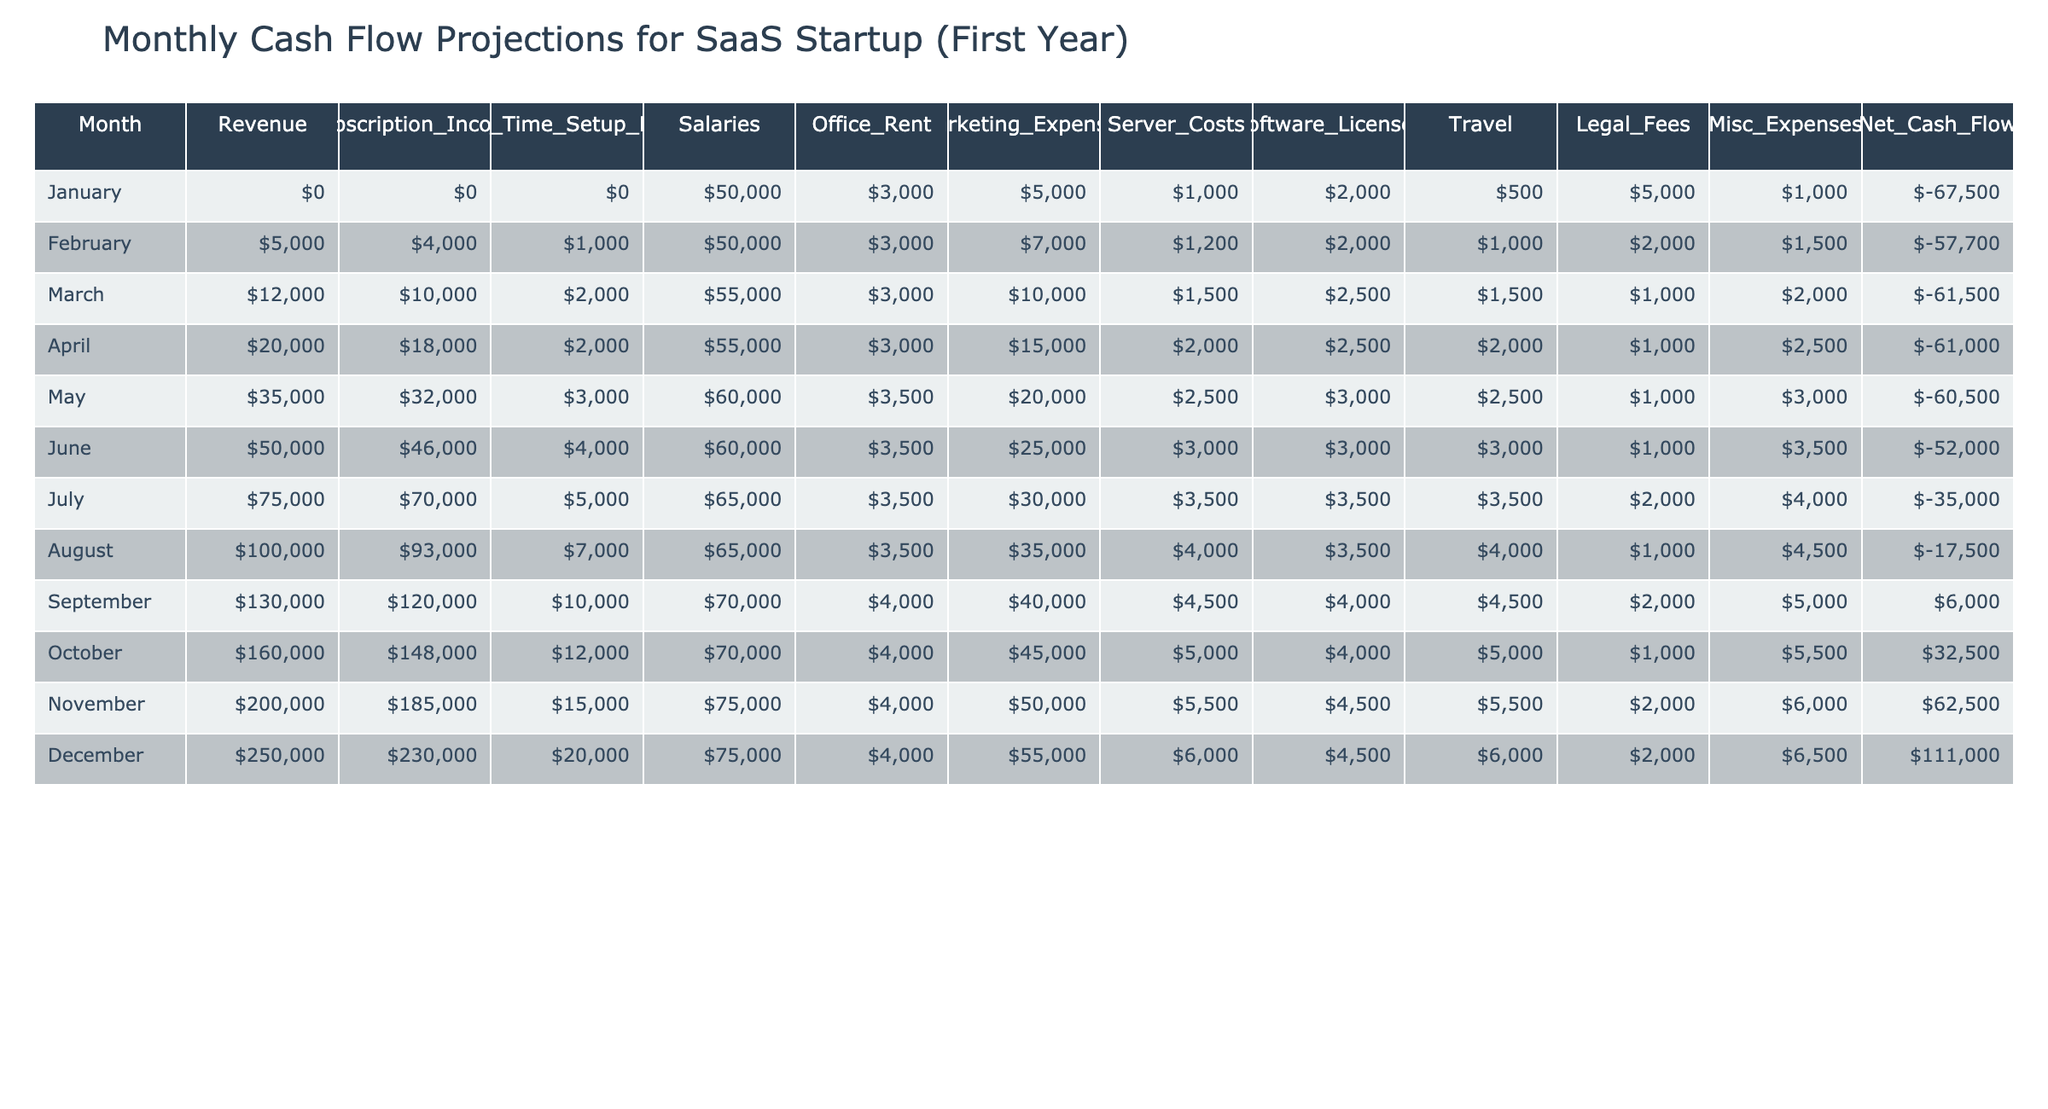What's the revenue in March? In the table, the revenue for March is listed directly in the corresponding row. It states that the revenue for March is $12,000.
Answer: $12,000 What is the total expenditure for April? To find the total expenditure for April, sum the Salaries, Office Rent, Marketing Expenses, Server Costs, Software Licenses, Travel, Legal Fees, and Misc Expenses. That is: $55,000 (Salaries) + $3,000 (Office Rent) + $15,000 (Marketing) + $2,000 (Server Costs) + $2,500 (Software Licenses) + $2,000 (Travel) + $1,000 (Legal Fees) + $2,500 (Misc) = $82,000.
Answer: $82,000 In which month did the net cash flow turn positive? Upon examining the net cash flow values in the table, I can see that net cash flow became positive in September with a net cash flow of $6,000.
Answer: September What is the average subscription income over the first year? To find the average subscription income, we first add up all monthly subscription incomes: $0 + $4,000 + $10,000 + $18,000 + $32,000 + $46,000 + $70,000 + $93,000 + $120,000 + $148,000 + $185,000 + $230,000 = $1,067,000. Then divide by 12 months: $1,067,000 / 12 = $88,917.
Answer: $88,917 Is there any month where marketing expenses were more than $30,000? By reviewing the marketing expenses of each month in the table, I find that the highest marketing expense is $35,000 in August, which confirms that there is indeed a month where expenses exceeded $30,000.
Answer: Yes What’s the difference in net cash flow between October and August? The net cash flow for October is $32,500, and for August, it's -$17,500. The difference can be calculated by subtracting the August value from October: $32,500 - (-$17,500) = $32,500 + $17,500 = $50,000.
Answer: $50,000 What is the total revenue across all months in the year? Summing the revenue for each month yields $0 + $5,000 + $12,000 + $20,000 + $35,000 + $50,000 + $75,000 + $100,000 + $130,000 + $160,000 + $200,000 + $250,000 = $1,360,000.
Answer: $1,360,000 Which month saw the highest one-time setup fees? The one-time setup fees across the months indicate that December had the highest fees at $20,000.
Answer: December What is the median salary expense over the year? To find the median salary expense, list the salary expenses: $50,000, $50,000, $55,000, $55,000, $60,000, $60,000, $65,000, $65,000, $70,000, $75,000, $75,000, $75,000. With 12 values, the median will be the average of the 6th and 7th values: ($60,000 + $65,000) / 2 = $62,500.
Answer: $62,500 How much did legal fees accumulate over the first year? Adding the legal fees for each month: $500 + $1,000 + $1,500 + $1,000 + $1,000 + $1,000 + $2,000 + $1,000 + $2,000 + $1,000 + $2,000 + $2,000 = $15,000 gives the total for legal fees throughout the year.
Answer: $15,000 